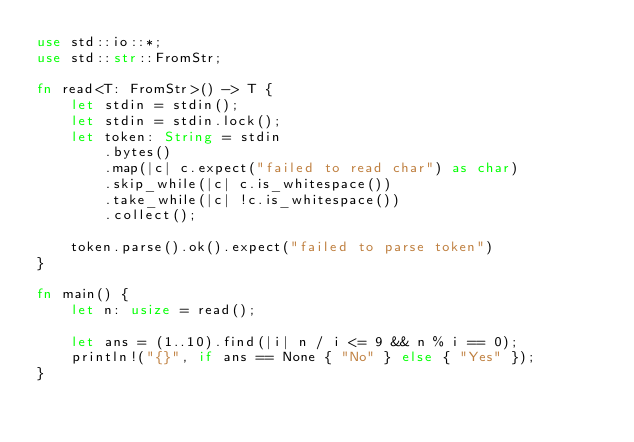Convert code to text. <code><loc_0><loc_0><loc_500><loc_500><_Rust_>use std::io::*;
use std::str::FromStr;

fn read<T: FromStr>() -> T {
    let stdin = stdin();
    let stdin = stdin.lock();
    let token: String = stdin
        .bytes()
        .map(|c| c.expect("failed to read char") as char)
        .skip_while(|c| c.is_whitespace())
        .take_while(|c| !c.is_whitespace())
        .collect();

    token.parse().ok().expect("failed to parse token")
}

fn main() {
    let n: usize = read();

    let ans = (1..10).find(|i| n / i <= 9 && n % i == 0);
    println!("{}", if ans == None { "No" } else { "Yes" });
}
</code> 